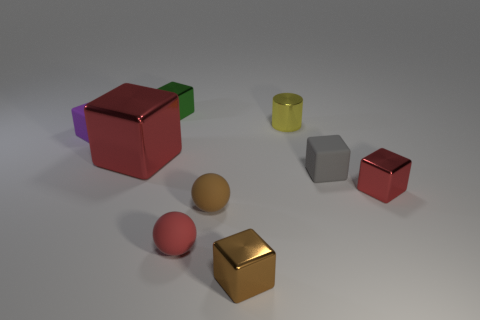Subtract all large cubes. How many cubes are left? 5 Subtract all red cubes. How many cubes are left? 4 Subtract 1 balls. How many balls are left? 1 Add 9 gray cubes. How many gray cubes are left? 10 Add 3 purple blocks. How many purple blocks exist? 4 Subtract 1 red balls. How many objects are left? 8 Subtract all balls. How many objects are left? 7 Subtract all green balls. Subtract all green cubes. How many balls are left? 2 Subtract all blue cubes. How many purple cylinders are left? 0 Subtract all red balls. Subtract all tiny balls. How many objects are left? 6 